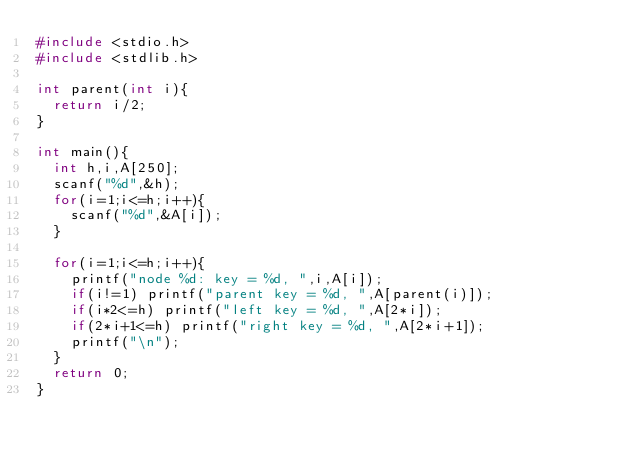Convert code to text. <code><loc_0><loc_0><loc_500><loc_500><_C_>#include <stdio.h>
#include <stdlib.h>

int parent(int i){
  return i/2;
}

int main(){
  int h,i,A[250];
  scanf("%d",&h);
  for(i=1;i<=h;i++){
    scanf("%d",&A[i]);
  }

  for(i=1;i<=h;i++){
    printf("node %d: key = %d, ",i,A[i]);
    if(i!=1) printf("parent key = %d, ",A[parent(i)]);
    if(i*2<=h) printf("left key = %d, ",A[2*i]);
    if(2*i+1<=h) printf("right key = %d, ",A[2*i+1]);
    printf("\n");
  }
  return 0;
}</code> 